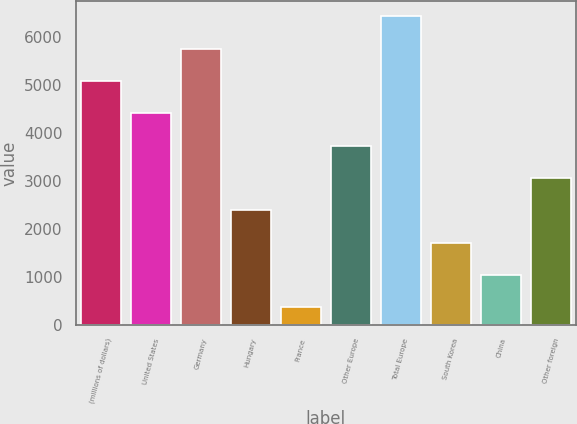<chart> <loc_0><loc_0><loc_500><loc_500><bar_chart><fcel>(millions of dollars)<fcel>United States<fcel>Germany<fcel>Hungary<fcel>France<fcel>Other Europe<fcel>Total Europe<fcel>South Korea<fcel>China<fcel>Other foreign<nl><fcel>5089.19<fcel>4414.02<fcel>5764.36<fcel>2388.51<fcel>363<fcel>3738.85<fcel>6439.53<fcel>1713.34<fcel>1038.17<fcel>3063.68<nl></chart> 